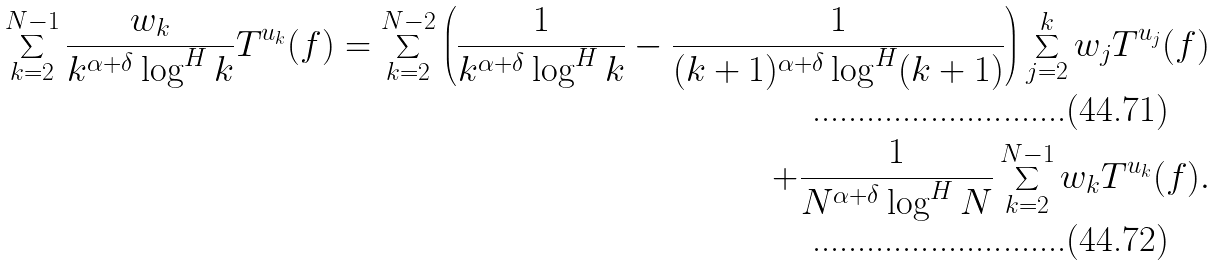Convert formula to latex. <formula><loc_0><loc_0><loc_500><loc_500>\sum _ { k = 2 } ^ { N - 1 } \frac { w _ { k } } { k ^ { \alpha + \delta } \log ^ { H } k } T ^ { u _ { k } } ( f ) = \sum _ { k = 2 } ^ { N - 2 } \left ( \frac { 1 } { k ^ { \alpha + \delta } \log ^ { H } k } - \frac { 1 } { ( k + 1 ) ^ { \alpha + \delta } \log ^ { H } ( k + 1 ) } \right ) \sum _ { j = 2 } ^ { k } w _ { j } T ^ { u _ { j } } ( f ) \\ + \frac { 1 } { N ^ { \alpha + \delta } \log ^ { H } N } \sum _ { k = 2 } ^ { N - 1 } w _ { k } T ^ { u _ { k } } ( f ) .</formula> 